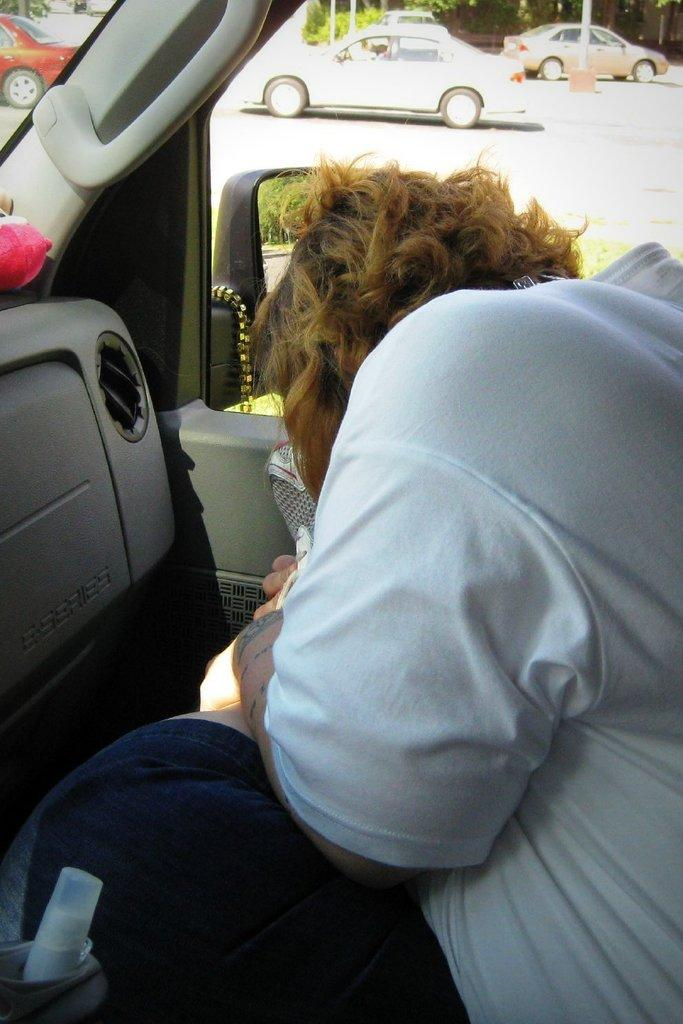What is happening in the image involving a person? There is a person inside a vehicle in the image. What can be seen through the vehicle? Other vehicles are visible through the vehicle. What type of natural scenery is present in the image? There are trees in the image. What man-made structures are visible in the image? There are poles in the image. What object is located at the bottom of the image? There is a bottle at the bottom of the image. Are there any pets visible in the image? There are no pets visible in the image. Can you describe the stretching exercise the person is doing in the vehicle? The person is not performing any stretching exercises in the vehicle; they are simply inside the vehicle. 